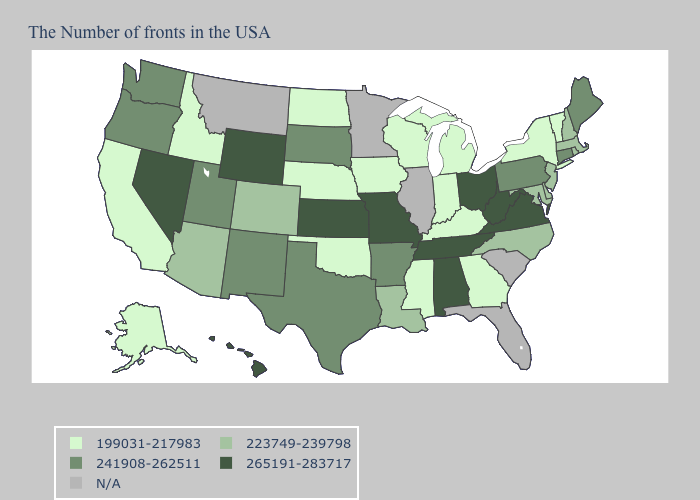What is the value of Colorado?
Concise answer only. 223749-239798. Does Connecticut have the lowest value in the USA?
Quick response, please. No. What is the value of Texas?
Write a very short answer. 241908-262511. Which states have the lowest value in the USA?
Concise answer only. Vermont, New York, Georgia, Michigan, Kentucky, Indiana, Wisconsin, Mississippi, Iowa, Nebraska, Oklahoma, North Dakota, Idaho, California, Alaska. What is the highest value in the USA?
Concise answer only. 265191-283717. What is the value of Indiana?
Concise answer only. 199031-217983. What is the value of Ohio?
Answer briefly. 265191-283717. What is the value of Maine?
Answer briefly. 241908-262511. Name the states that have a value in the range 199031-217983?
Give a very brief answer. Vermont, New York, Georgia, Michigan, Kentucky, Indiana, Wisconsin, Mississippi, Iowa, Nebraska, Oklahoma, North Dakota, Idaho, California, Alaska. Does the map have missing data?
Short answer required. Yes. What is the value of New Hampshire?
Concise answer only. 223749-239798. What is the value of New Jersey?
Be succinct. 223749-239798. Name the states that have a value in the range 241908-262511?
Short answer required. Maine, Connecticut, Pennsylvania, Arkansas, Texas, South Dakota, New Mexico, Utah, Washington, Oregon. What is the value of South Dakota?
Answer briefly. 241908-262511. Which states have the lowest value in the USA?
Short answer required. Vermont, New York, Georgia, Michigan, Kentucky, Indiana, Wisconsin, Mississippi, Iowa, Nebraska, Oklahoma, North Dakota, Idaho, California, Alaska. 